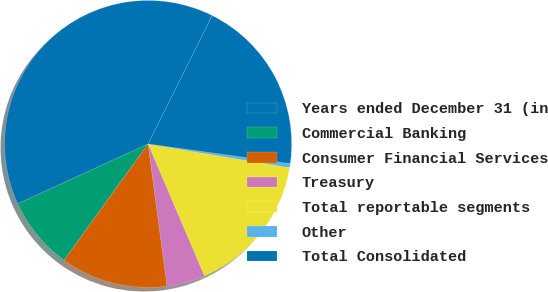Convert chart to OTSL. <chart><loc_0><loc_0><loc_500><loc_500><pie_chart><fcel>Years ended December 31 (in<fcel>Commercial Banking<fcel>Consumer Financial Services<fcel>Treasury<fcel>Total reportable segments<fcel>Other<fcel>Total Consolidated<nl><fcel>39.22%<fcel>8.19%<fcel>12.07%<fcel>4.31%<fcel>15.95%<fcel>0.44%<fcel>19.83%<nl></chart> 